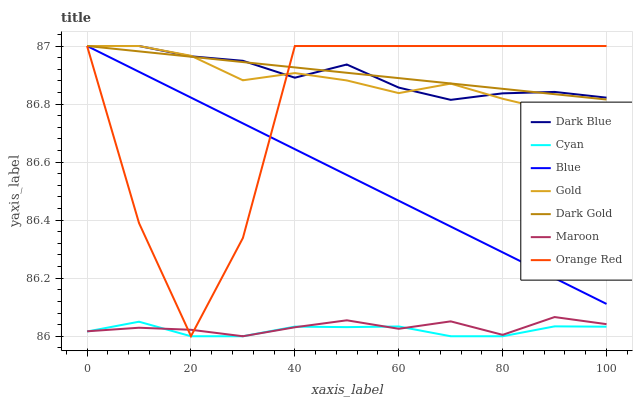Does Cyan have the minimum area under the curve?
Answer yes or no. Yes. Does Dark Gold have the maximum area under the curve?
Answer yes or no. Yes. Does Gold have the minimum area under the curve?
Answer yes or no. No. Does Gold have the maximum area under the curve?
Answer yes or no. No. Is Dark Gold the smoothest?
Answer yes or no. Yes. Is Orange Red the roughest?
Answer yes or no. Yes. Is Gold the smoothest?
Answer yes or no. No. Is Gold the roughest?
Answer yes or no. No. Does Maroon have the lowest value?
Answer yes or no. Yes. Does Gold have the lowest value?
Answer yes or no. No. Does Orange Red have the highest value?
Answer yes or no. Yes. Does Maroon have the highest value?
Answer yes or no. No. Is Cyan less than Dark Gold?
Answer yes or no. Yes. Is Gold greater than Maroon?
Answer yes or no. Yes. Does Cyan intersect Maroon?
Answer yes or no. Yes. Is Cyan less than Maroon?
Answer yes or no. No. Is Cyan greater than Maroon?
Answer yes or no. No. Does Cyan intersect Dark Gold?
Answer yes or no. No. 